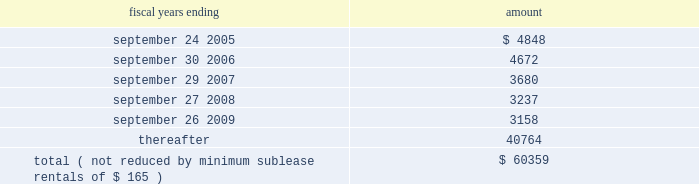Hologic , inc .
Notes to consolidated financial statements 2014 ( continued ) ( in thousands , except per share data ) future minimum lease payments under all the company 2019s operating leases are approximately as follows: .
The company subleases a portion of its bedford facility and has received rental income of $ 277 , $ 410 and $ 682 for fiscal years 2004 , 2003 and 2002 , respectively , which has been recorded as an offset to rent expense in the accompanying statements of income .
Rental expense , net of sublease income , was approximately $ 4660 , $ 4963 , and $ 2462 for fiscal 2004 , 2003 and 2002 , respectively .
Business segments and geographic information the company reports segment information in accordance with sfas no .
131 , disclosures about segments of an enterprise and related information .
Operating segments are identified as components of an enterprise about which separate , discrete financial information is available for evaluation by the chief operating decision maker , or decision-making group , in making decisions how to allocate resources and assess performance .
The company 2019s chief decision-maker , as defined under sfas no .
131 , is the chief executive officer .
To date , the company has viewed its operations and manages its business as four principal operating segments : the manufacture and sale of mammography products , osteoporosis assessment products , digital detectors and other products .
As a result of the company 2019s implementation of a company wide integrated software application in fiscal 2003 , identifiable assets for the four principal operating segments only consist of inventories , intangible assets , and property and equipment .
The company has presented all other assets as corporate assets .
Prior periods have been restated to conform to this presentation .
Intersegment sales and transfers are not significant. .
What was the percentage change in rental expense between 2002 and 2003? 
Computations: ((4963 - 2462) / 2462)
Answer: 1.01584. 